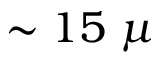<formula> <loc_0><loc_0><loc_500><loc_500>\sim 1 5 \mu</formula> 